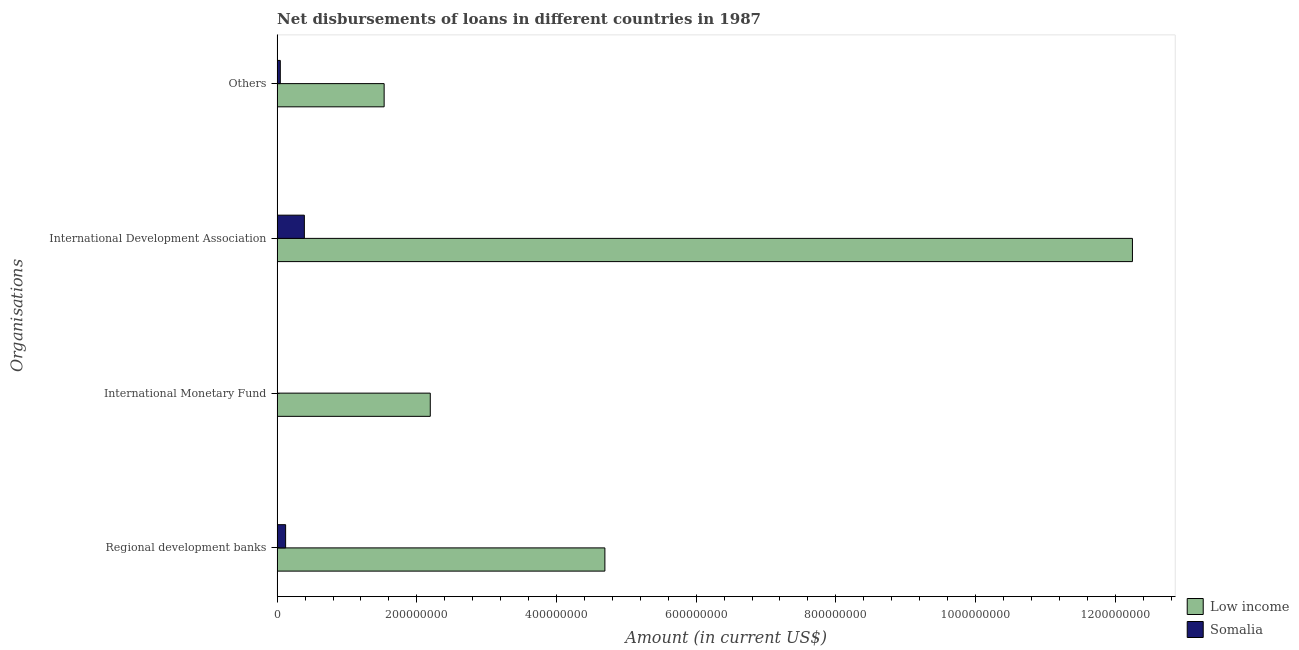Are the number of bars per tick equal to the number of legend labels?
Offer a very short reply. No. How many bars are there on the 2nd tick from the bottom?
Offer a terse response. 1. What is the label of the 1st group of bars from the top?
Give a very brief answer. Others. What is the amount of loan disimbursed by international monetary fund in Low income?
Offer a terse response. 2.19e+08. Across all countries, what is the maximum amount of loan disimbursed by regional development banks?
Keep it short and to the point. 4.69e+08. Across all countries, what is the minimum amount of loan disimbursed by international development association?
Make the answer very short. 3.90e+07. In which country was the amount of loan disimbursed by international development association maximum?
Provide a succinct answer. Low income. What is the total amount of loan disimbursed by regional development banks in the graph?
Provide a short and direct response. 4.82e+08. What is the difference between the amount of loan disimbursed by other organisations in Somalia and that in Low income?
Your answer should be very brief. -1.49e+08. What is the difference between the amount of loan disimbursed by international monetary fund in Low income and the amount of loan disimbursed by international development association in Somalia?
Your answer should be very brief. 1.80e+08. What is the average amount of loan disimbursed by other organisations per country?
Make the answer very short. 7.89e+07. What is the difference between the amount of loan disimbursed by international development association and amount of loan disimbursed by other organisations in Low income?
Your answer should be very brief. 1.07e+09. In how many countries, is the amount of loan disimbursed by regional development banks greater than 440000000 US$?
Keep it short and to the point. 1. What is the ratio of the amount of loan disimbursed by regional development banks in Low income to that in Somalia?
Provide a succinct answer. 38.58. Is the amount of loan disimbursed by regional development banks in Somalia less than that in Low income?
Your response must be concise. Yes. Is the difference between the amount of loan disimbursed by international development association in Low income and Somalia greater than the difference between the amount of loan disimbursed by other organisations in Low income and Somalia?
Give a very brief answer. Yes. What is the difference between the highest and the second highest amount of loan disimbursed by other organisations?
Provide a short and direct response. 1.49e+08. What is the difference between the highest and the lowest amount of loan disimbursed by other organisations?
Ensure brevity in your answer.  1.49e+08. Is the sum of the amount of loan disimbursed by international development association in Somalia and Low income greater than the maximum amount of loan disimbursed by regional development banks across all countries?
Provide a succinct answer. Yes. Is it the case that in every country, the sum of the amount of loan disimbursed by regional development banks and amount of loan disimbursed by international development association is greater than the sum of amount of loan disimbursed by other organisations and amount of loan disimbursed by international monetary fund?
Make the answer very short. No. Is it the case that in every country, the sum of the amount of loan disimbursed by regional development banks and amount of loan disimbursed by international monetary fund is greater than the amount of loan disimbursed by international development association?
Your answer should be very brief. No. How many countries are there in the graph?
Keep it short and to the point. 2. Are the values on the major ticks of X-axis written in scientific E-notation?
Keep it short and to the point. No. Does the graph contain any zero values?
Ensure brevity in your answer.  Yes. Where does the legend appear in the graph?
Provide a succinct answer. Bottom right. How many legend labels are there?
Your response must be concise. 2. What is the title of the graph?
Provide a short and direct response. Net disbursements of loans in different countries in 1987. Does "Puerto Rico" appear as one of the legend labels in the graph?
Your answer should be very brief. No. What is the label or title of the X-axis?
Offer a terse response. Amount (in current US$). What is the label or title of the Y-axis?
Your answer should be compact. Organisations. What is the Amount (in current US$) of Low income in Regional development banks?
Ensure brevity in your answer.  4.69e+08. What is the Amount (in current US$) of Somalia in Regional development banks?
Your answer should be very brief. 1.22e+07. What is the Amount (in current US$) in Low income in International Monetary Fund?
Ensure brevity in your answer.  2.19e+08. What is the Amount (in current US$) of Low income in International Development Association?
Offer a terse response. 1.22e+09. What is the Amount (in current US$) of Somalia in International Development Association?
Make the answer very short. 3.90e+07. What is the Amount (in current US$) of Low income in Others?
Your answer should be compact. 1.53e+08. What is the Amount (in current US$) of Somalia in Others?
Your response must be concise. 4.55e+06. Across all Organisations, what is the maximum Amount (in current US$) of Low income?
Offer a very short reply. 1.22e+09. Across all Organisations, what is the maximum Amount (in current US$) of Somalia?
Provide a short and direct response. 3.90e+07. Across all Organisations, what is the minimum Amount (in current US$) of Low income?
Provide a succinct answer. 1.53e+08. Across all Organisations, what is the minimum Amount (in current US$) of Somalia?
Offer a terse response. 0. What is the total Amount (in current US$) in Low income in the graph?
Provide a short and direct response. 2.07e+09. What is the total Amount (in current US$) in Somalia in the graph?
Your answer should be very brief. 5.57e+07. What is the difference between the Amount (in current US$) in Low income in Regional development banks and that in International Monetary Fund?
Your answer should be compact. 2.50e+08. What is the difference between the Amount (in current US$) of Low income in Regional development banks and that in International Development Association?
Offer a terse response. -7.55e+08. What is the difference between the Amount (in current US$) in Somalia in Regional development banks and that in International Development Association?
Provide a succinct answer. -2.68e+07. What is the difference between the Amount (in current US$) in Low income in Regional development banks and that in Others?
Provide a short and direct response. 3.16e+08. What is the difference between the Amount (in current US$) of Somalia in Regional development banks and that in Others?
Provide a succinct answer. 7.62e+06. What is the difference between the Amount (in current US$) of Low income in International Monetary Fund and that in International Development Association?
Make the answer very short. -1.01e+09. What is the difference between the Amount (in current US$) of Low income in International Monetary Fund and that in Others?
Your response must be concise. 6.61e+07. What is the difference between the Amount (in current US$) in Low income in International Development Association and that in Others?
Offer a terse response. 1.07e+09. What is the difference between the Amount (in current US$) in Somalia in International Development Association and that in Others?
Provide a succinct answer. 3.44e+07. What is the difference between the Amount (in current US$) in Low income in Regional development banks and the Amount (in current US$) in Somalia in International Development Association?
Offer a very short reply. 4.30e+08. What is the difference between the Amount (in current US$) of Low income in Regional development banks and the Amount (in current US$) of Somalia in Others?
Offer a terse response. 4.65e+08. What is the difference between the Amount (in current US$) of Low income in International Monetary Fund and the Amount (in current US$) of Somalia in International Development Association?
Keep it short and to the point. 1.80e+08. What is the difference between the Amount (in current US$) in Low income in International Monetary Fund and the Amount (in current US$) in Somalia in Others?
Your answer should be compact. 2.15e+08. What is the difference between the Amount (in current US$) in Low income in International Development Association and the Amount (in current US$) in Somalia in Others?
Your answer should be very brief. 1.22e+09. What is the average Amount (in current US$) in Low income per Organisations?
Ensure brevity in your answer.  5.17e+08. What is the average Amount (in current US$) of Somalia per Organisations?
Your response must be concise. 1.39e+07. What is the difference between the Amount (in current US$) of Low income and Amount (in current US$) of Somalia in Regional development banks?
Offer a very short reply. 4.57e+08. What is the difference between the Amount (in current US$) of Low income and Amount (in current US$) of Somalia in International Development Association?
Your response must be concise. 1.19e+09. What is the difference between the Amount (in current US$) of Low income and Amount (in current US$) of Somalia in Others?
Make the answer very short. 1.49e+08. What is the ratio of the Amount (in current US$) in Low income in Regional development banks to that in International Monetary Fund?
Provide a succinct answer. 2.14. What is the ratio of the Amount (in current US$) in Low income in Regional development banks to that in International Development Association?
Offer a very short reply. 0.38. What is the ratio of the Amount (in current US$) of Somalia in Regional development banks to that in International Development Association?
Give a very brief answer. 0.31. What is the ratio of the Amount (in current US$) in Low income in Regional development banks to that in Others?
Offer a very short reply. 3.06. What is the ratio of the Amount (in current US$) in Somalia in Regional development banks to that in Others?
Your answer should be very brief. 2.68. What is the ratio of the Amount (in current US$) of Low income in International Monetary Fund to that in International Development Association?
Give a very brief answer. 0.18. What is the ratio of the Amount (in current US$) of Low income in International Monetary Fund to that in Others?
Offer a terse response. 1.43. What is the ratio of the Amount (in current US$) of Low income in International Development Association to that in Others?
Provide a short and direct response. 7.99. What is the ratio of the Amount (in current US$) in Somalia in International Development Association to that in Others?
Offer a terse response. 8.58. What is the difference between the highest and the second highest Amount (in current US$) of Low income?
Ensure brevity in your answer.  7.55e+08. What is the difference between the highest and the second highest Amount (in current US$) of Somalia?
Ensure brevity in your answer.  2.68e+07. What is the difference between the highest and the lowest Amount (in current US$) in Low income?
Give a very brief answer. 1.07e+09. What is the difference between the highest and the lowest Amount (in current US$) of Somalia?
Provide a short and direct response. 3.90e+07. 